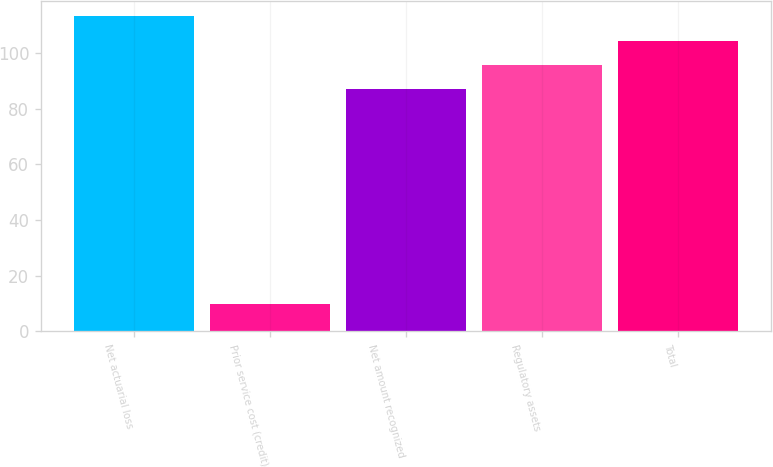Convert chart. <chart><loc_0><loc_0><loc_500><loc_500><bar_chart><fcel>Net actuarial loss<fcel>Prior service cost (credit)<fcel>Net amount recognized<fcel>Regulatory assets<fcel>Total<nl><fcel>113.1<fcel>10<fcel>87<fcel>95.7<fcel>104.4<nl></chart> 